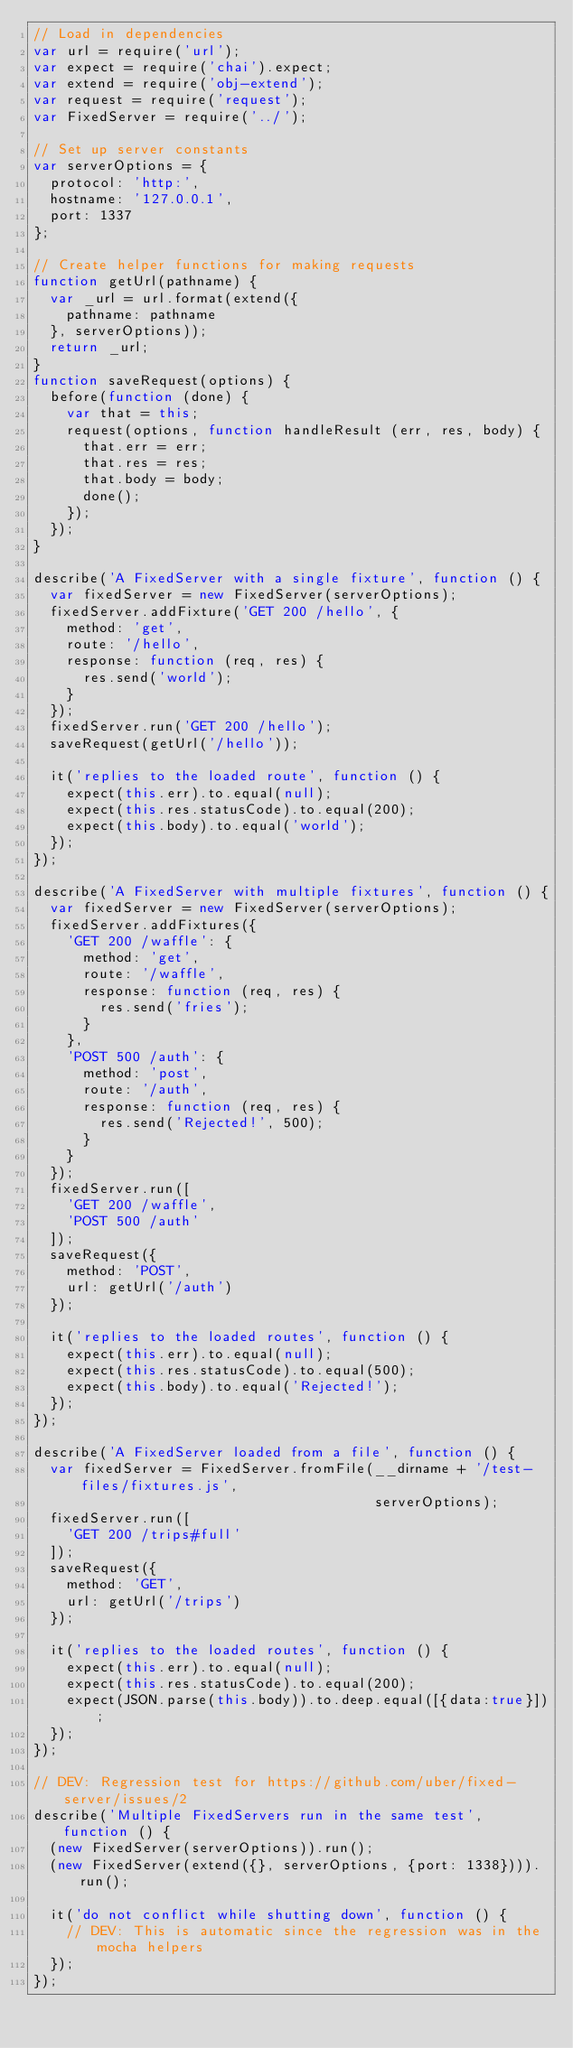Convert code to text. <code><loc_0><loc_0><loc_500><loc_500><_JavaScript_>// Load in dependencies
var url = require('url');
var expect = require('chai').expect;
var extend = require('obj-extend');
var request = require('request');
var FixedServer = require('../');

// Set up server constants
var serverOptions = {
  protocol: 'http:',
  hostname: '127.0.0.1',
  port: 1337
};

// Create helper functions for making requests
function getUrl(pathname) {
  var _url = url.format(extend({
    pathname: pathname
  }, serverOptions));
  return _url;
}
function saveRequest(options) {
  before(function (done) {
    var that = this;
    request(options, function handleResult (err, res, body) {
      that.err = err;
      that.res = res;
      that.body = body;
      done();
    });
  });
}

describe('A FixedServer with a single fixture', function () {
  var fixedServer = new FixedServer(serverOptions);
  fixedServer.addFixture('GET 200 /hello', {
    method: 'get',
    route: '/hello',
    response: function (req, res) {
      res.send('world');
    }
  });
  fixedServer.run('GET 200 /hello');
  saveRequest(getUrl('/hello'));

  it('replies to the loaded route', function () {
    expect(this.err).to.equal(null);
    expect(this.res.statusCode).to.equal(200);
    expect(this.body).to.equal('world');
  });
});

describe('A FixedServer with multiple fixtures', function () {
  var fixedServer = new FixedServer(serverOptions);
  fixedServer.addFixtures({
    'GET 200 /waffle': {
      method: 'get',
      route: '/waffle',
      response: function (req, res) {
        res.send('fries');
      }
    },
    'POST 500 /auth': {
      method: 'post',
      route: '/auth',
      response: function (req, res) {
        res.send('Rejected!', 500);
      }
    }
  });
  fixedServer.run([
    'GET 200 /waffle',
    'POST 500 /auth'
  ]);
  saveRequest({
    method: 'POST',
    url: getUrl('/auth')
  });

  it('replies to the loaded routes', function () {
    expect(this.err).to.equal(null);
    expect(this.res.statusCode).to.equal(500);
    expect(this.body).to.equal('Rejected!');
  });
});

describe('A FixedServer loaded from a file', function () {
  var fixedServer = FixedServer.fromFile(__dirname + '/test-files/fixtures.js',
                                         serverOptions);
  fixedServer.run([
    'GET 200 /trips#full'
  ]);
  saveRequest({
    method: 'GET',
    url: getUrl('/trips')
  });

  it('replies to the loaded routes', function () {
    expect(this.err).to.equal(null);
    expect(this.res.statusCode).to.equal(200);
    expect(JSON.parse(this.body)).to.deep.equal([{data:true}]);
  });
});

// DEV: Regression test for https://github.com/uber/fixed-server/issues/2
describe('Multiple FixedServers run in the same test', function () {
  (new FixedServer(serverOptions)).run();
  (new FixedServer(extend({}, serverOptions, {port: 1338}))).run();

  it('do not conflict while shutting down', function () {
    // DEV: This is automatic since the regression was in the mocha helpers
  });
});
</code> 